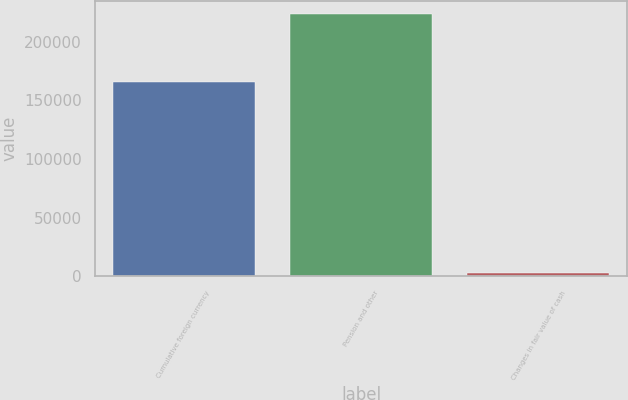Convert chart to OTSL. <chart><loc_0><loc_0><loc_500><loc_500><bar_chart><fcel>Cumulative foreign currency<fcel>Pension and other<fcel>Changes in fair value of cash<nl><fcel>165872<fcel>223887<fcel>3109<nl></chart> 